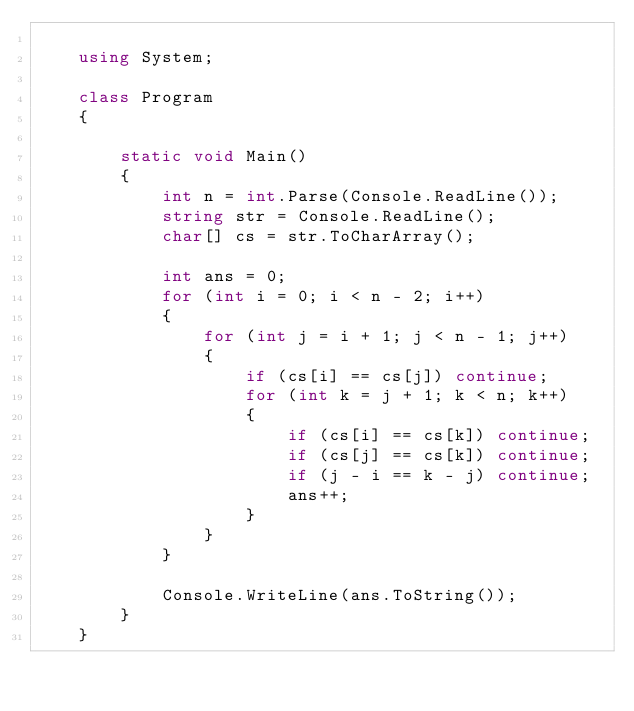<code> <loc_0><loc_0><loc_500><loc_500><_C#_>
    using System;

    class Program
    {

        static void Main()
        {
            int n = int.Parse(Console.ReadLine());
            string str = Console.ReadLine();
            char[] cs = str.ToCharArray();

            int ans = 0;
            for (int i = 0; i < n - 2; i++)
            {
                for (int j = i + 1; j < n - 1; j++)
                {
                    if (cs[i] == cs[j]) continue;
                    for (int k = j + 1; k < n; k++)
                    {
                        if (cs[i] == cs[k]) continue;
                        if (cs[j] == cs[k]) continue;
                        if (j - i == k - j) continue;
                        ans++;
                    }
                }
            }

            Console.WriteLine(ans.ToString());
        }
    }</code> 